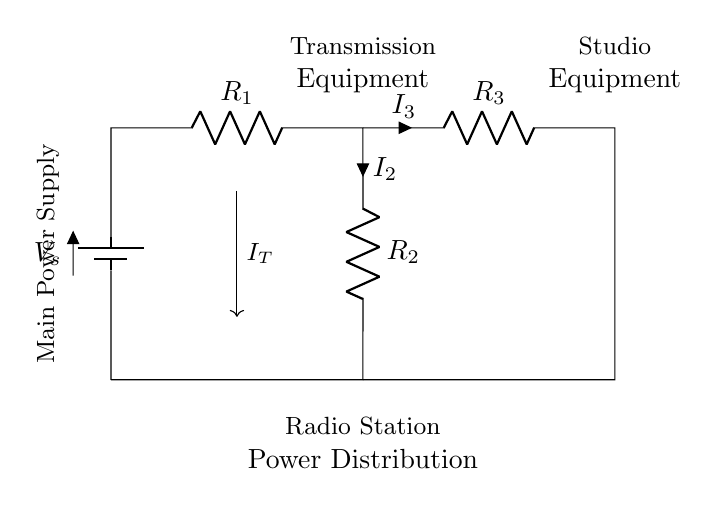What is the total current entering the circuit? The total current entering the circuit is indicated by the symbol \( I_T \) in the diagram. It is shown flowing downward from the transmission equipment to the main junction where the resistors split the current.
Answer: Total current What components are present in this circuit? The circuit includes a voltage source (battery), three resistors \( R_1 \), \( R_2 \), and \( R_3 \), and is connected to transmission and studio equipment. The symbols this diagram uses specifically represent these elements visually.
Answer: Voltage source, resistors, equipment What is the connection type between the resistors? The resistors \( R_1 \) and \( R_2 \) are in parallel, as indicated by their configuration where they share both the same upper and lower nodes. This is a characteristic of a current divider circuit, which allows the total current to be divided among parallel paths.
Answer: Parallel Which portion of the circuit represents the broadcasting equipment? The upper section labeled "Transmission Equipment" (on the left side) and "Studio Equipment" (on the right side) indicate where the broadcasting equipment is connected in this circuit.
Answer: Transmission and studio equipment If the total current is five amperes, what is the current through \( R_2 \)? To find the current through \( R_2 \), we know that in a current divider circuit, the current splits inversely with respect to the resistance values. If the total current is five amperes, more specific calculations need to determine current in \( R_2 \), based on the resistor values which are not provided. Thus we can't give a precise figure.
Answer: Cannot determine Which resistor has the highest current through it? Based on the current divider rule, the resistor with the lowest resistance will have the highest current. Given the values of \( R_1 \), \( R_2 \), and \( R_3 \) are not specified, we cannot determine directly which resistor will have the highest current.
Answer: Cannot determine 